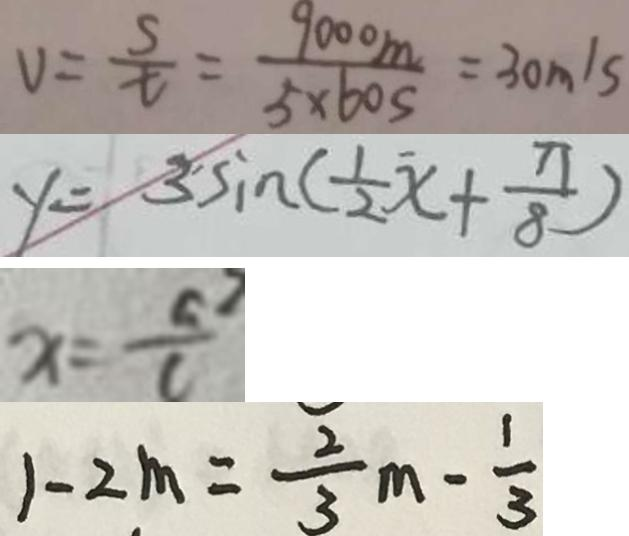Convert formula to latex. <formula><loc_0><loc_0><loc_500><loc_500>V = \frac { s } { t } = \frac { 9 0 0 0 m } { 5 \times 6 0 s } = 3 0 m / s 
 y = 3 \sin ( \frac { 1 } { 2 } x + \frac { \pi } { 8 } ) 
 x = \frac { a ^ { 2 } } { c } 
 1 - 2 m = \frac { 2 } { 3 } m - \frac { 1 } { 3 }</formula> 